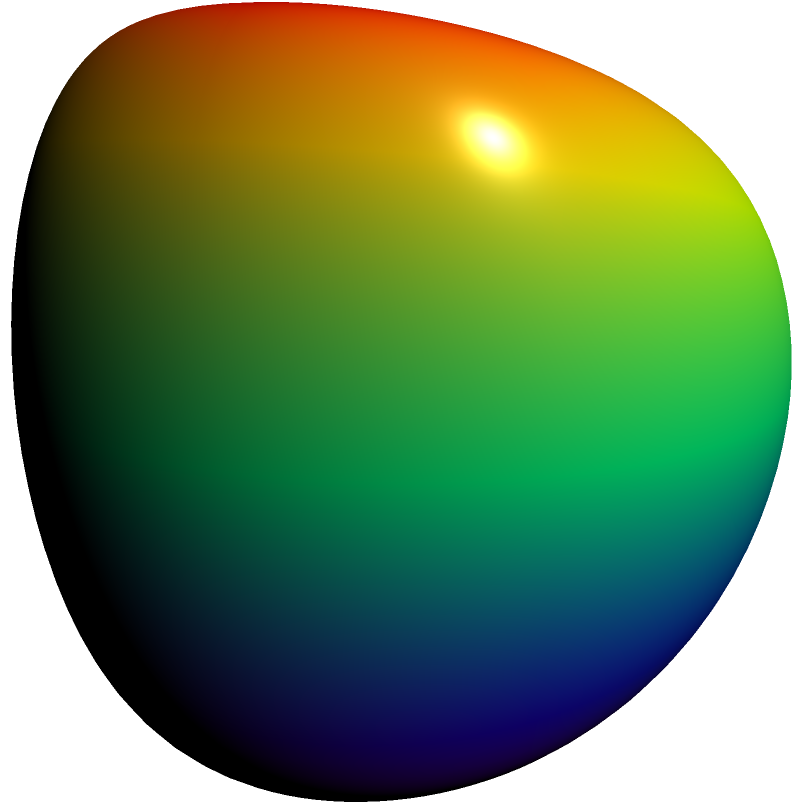In the context of data visualization for academic publications, how does the non-orientability of a Klein bottle, as shown in the figure, impact the representation of multidimensional datasets? Propose a specific application where this topological property could be advantageous. To answer this question, let's break it down into steps:

1. Understanding the Klein bottle:
   - A Klein bottle is a non-orientable surface with no inside or outside.
   - It can be represented in 3D space, as shown in the figure, but it actually exists in 4D space.

2. Non-orientability in data visualization:
   - Non-orientability allows for continuous transitions between seemingly opposite sides of a surface.
   - This property can be used to represent cyclical or interconnected data without artificial boundaries.

3. Impact on multidimensional datasets:
   - Multidimensional datasets often have complex relationships that are difficult to represent in traditional 2D or 3D visualizations.
   - The Klein bottle's topology allows for the representation of data points that may seem disconnected in lower dimensions but are actually related in higher dimensions.

4. Advantages in data representation:
   - Continuous data flow: The non-orientability allows for smooth transitions between data points that might seem disconnected in other representations.
   - Cyclic data: Perfect for representing data with cyclical patterns or periodic behaviors.
   - Interconnected variables: Useful for showing relationships between variables that are mutually influential.

5. Specific application:
   - Gene expression analysis in bioinformatics:
     - Genes often have complex regulatory networks with cyclical behaviors.
     - The Klein bottle topology can represent the continuous nature of gene expression levels and the interconnectedness of regulatory pathways.
     - It can visualize how seemingly unrelated genes might be connected through higher-dimensional relationships in the regulatory network.

6. Advantage in this application:
   - The non-orientability allows researchers to see how gene expression patterns that appear distinct in lower-dimensional representations might actually be closely related when considering the full complexity of the regulatory network.
   - This could lead to the discovery of new relationships between genes and potentially uncover novel regulatory mechanisms.
Answer: Gene expression analysis in bioinformatics, leveraging the Klein bottle's non-orientability to visualize complex, cyclical regulatory networks and uncover hidden relationships between genes. 